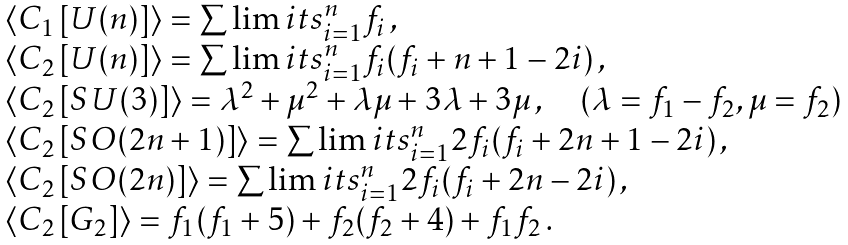Convert formula to latex. <formula><loc_0><loc_0><loc_500><loc_500>\begin{array} { l } \langle C _ { 1 } \left [ U ( n ) \right ] \rangle = \sum \lim i t s _ { i = 1 } ^ { n } f _ { i } \, , \\ \langle C _ { 2 } \left [ U ( n ) \right ] \rangle = \sum \lim i t s _ { i = 1 } ^ { n } f _ { i } ( f _ { i } + n + 1 - 2 i ) \, , \\ \langle C _ { 2 } \left [ S U ( 3 ) \right ] \rangle = \lambda ^ { 2 } + \mu ^ { 2 } + \lambda \mu + 3 \lambda + 3 \mu \, , \quad ( \lambda = f _ { 1 } - f _ { 2 } , \mu = f _ { 2 } ) \\ \langle C _ { 2 } \left [ S O ( 2 n + 1 ) \right ] \rangle = \sum \lim i t s _ { i = 1 } ^ { n } 2 f _ { i } ( f _ { i } + 2 n + 1 - 2 i ) \, , \\ \langle C _ { 2 } \left [ S O ( 2 n ) \right ] \rangle = \sum \lim i t s _ { i = 1 } ^ { n } 2 f _ { i } ( f _ { i } + 2 n - 2 i ) \, , \\ \langle C _ { 2 } \left [ G _ { 2 } \right ] \rangle = f _ { 1 } ( f _ { 1 } + 5 ) + f _ { 2 } ( f _ { 2 } + 4 ) + f _ { 1 } f _ { 2 } \, . \end{array}</formula> 